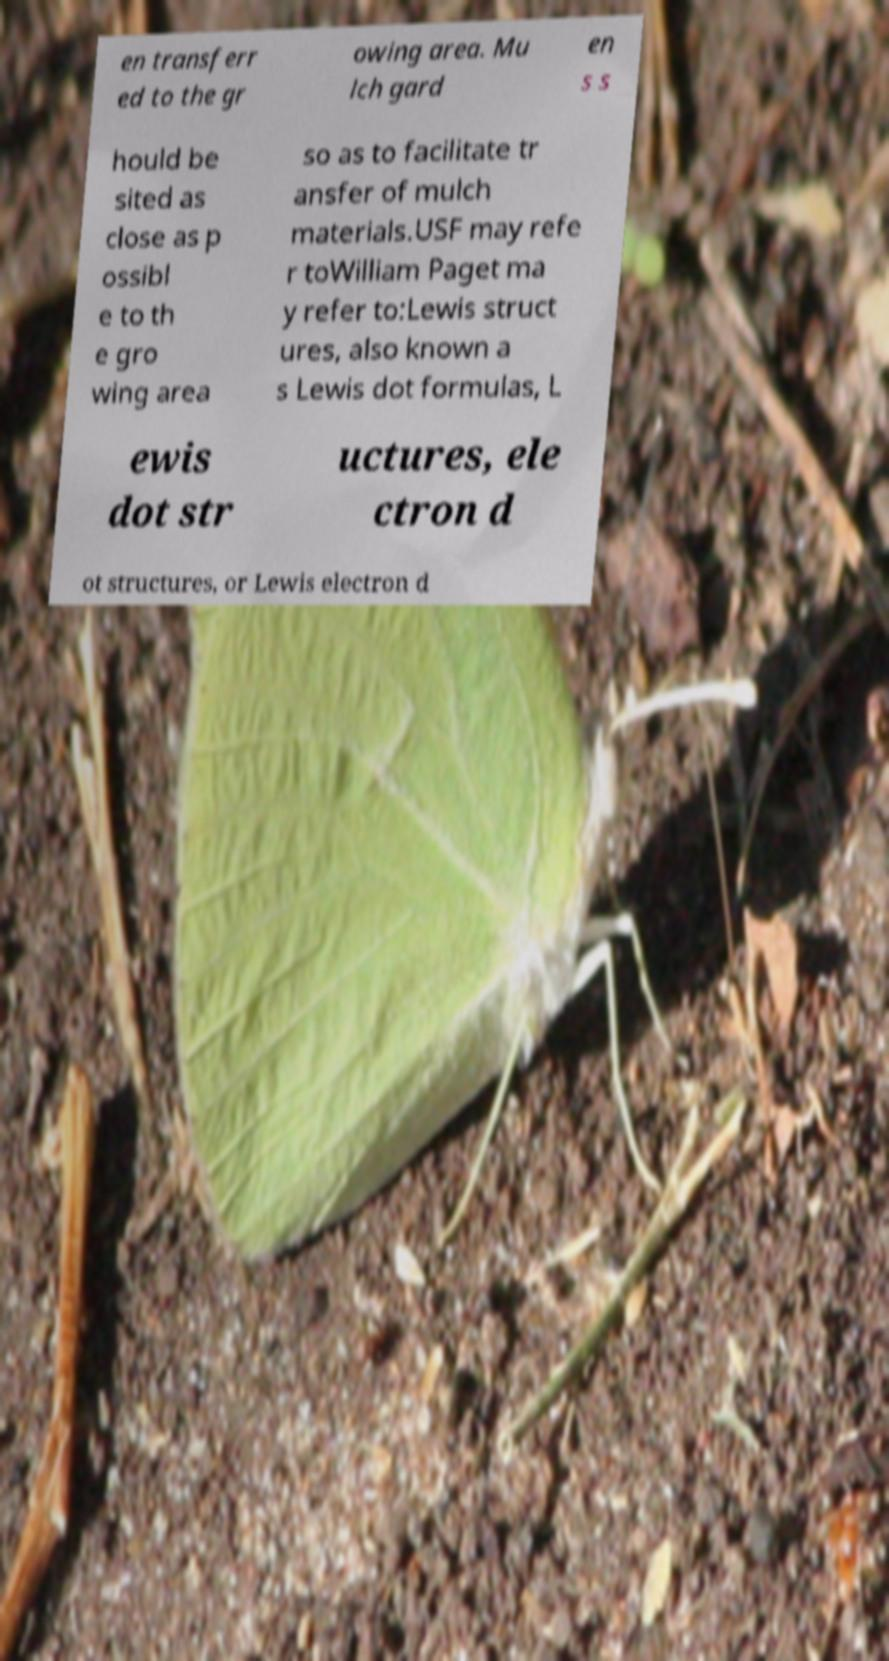I need the written content from this picture converted into text. Can you do that? en transferr ed to the gr owing area. Mu lch gard en s s hould be sited as close as p ossibl e to th e gro wing area so as to facilitate tr ansfer of mulch materials.USF may refe r toWilliam Paget ma y refer to:Lewis struct ures, also known a s Lewis dot formulas, L ewis dot str uctures, ele ctron d ot structures, or Lewis electron d 